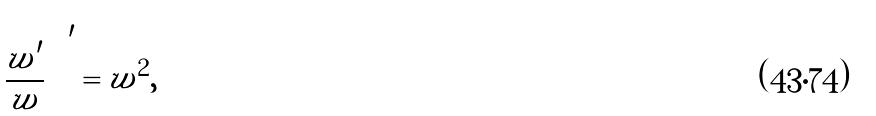<formula> <loc_0><loc_0><loc_500><loc_500>\left ( \frac { w ^ { \prime } } { w } \right ) ^ { \, \prime } = w ^ { 2 } ,</formula> 